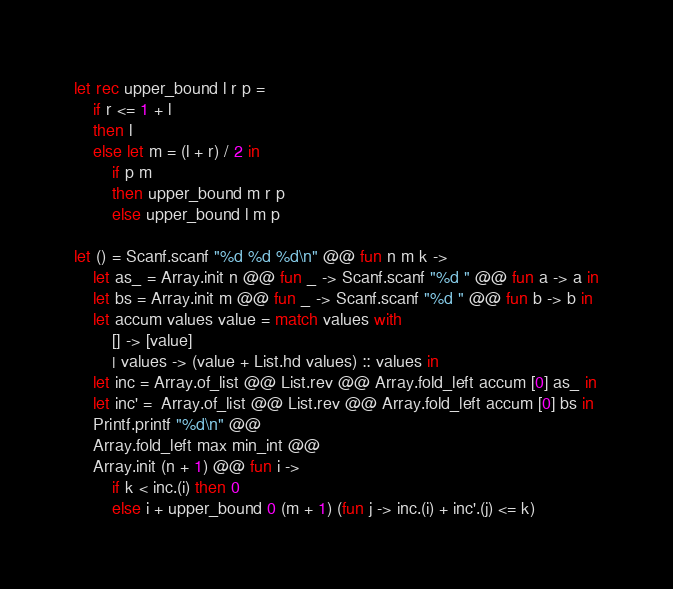<code> <loc_0><loc_0><loc_500><loc_500><_OCaml_>let rec upper_bound l r p =
    if r <= 1 + l
    then l
    else let m = (l + r) / 2 in
        if p m 
        then upper_bound m r p
        else upper_bound l m p

let () = Scanf.scanf "%d %d %d\n" @@ fun n m k ->
    let as_ = Array.init n @@ fun _ -> Scanf.scanf "%d " @@ fun a -> a in
    let bs = Array.init m @@ fun _ -> Scanf.scanf "%d " @@ fun b -> b in
    let accum values value = match values with
        [] -> [value]
        | values -> (value + List.hd values) :: values in
    let inc = Array.of_list @@ List.rev @@ Array.fold_left accum [0] as_ in
    let inc' =  Array.of_list @@ List.rev @@ Array.fold_left accum [0] bs in
    Printf.printf "%d\n" @@
    Array.fold_left max min_int @@
    Array.init (n + 1) @@ fun i ->
        if k < inc.(i) then 0
        else i + upper_bound 0 (m + 1) (fun j -> inc.(i) + inc'.(j) <= k)

</code> 